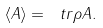<formula> <loc_0><loc_0><loc_500><loc_500>\langle A \rangle = \ t r \rho A .</formula> 